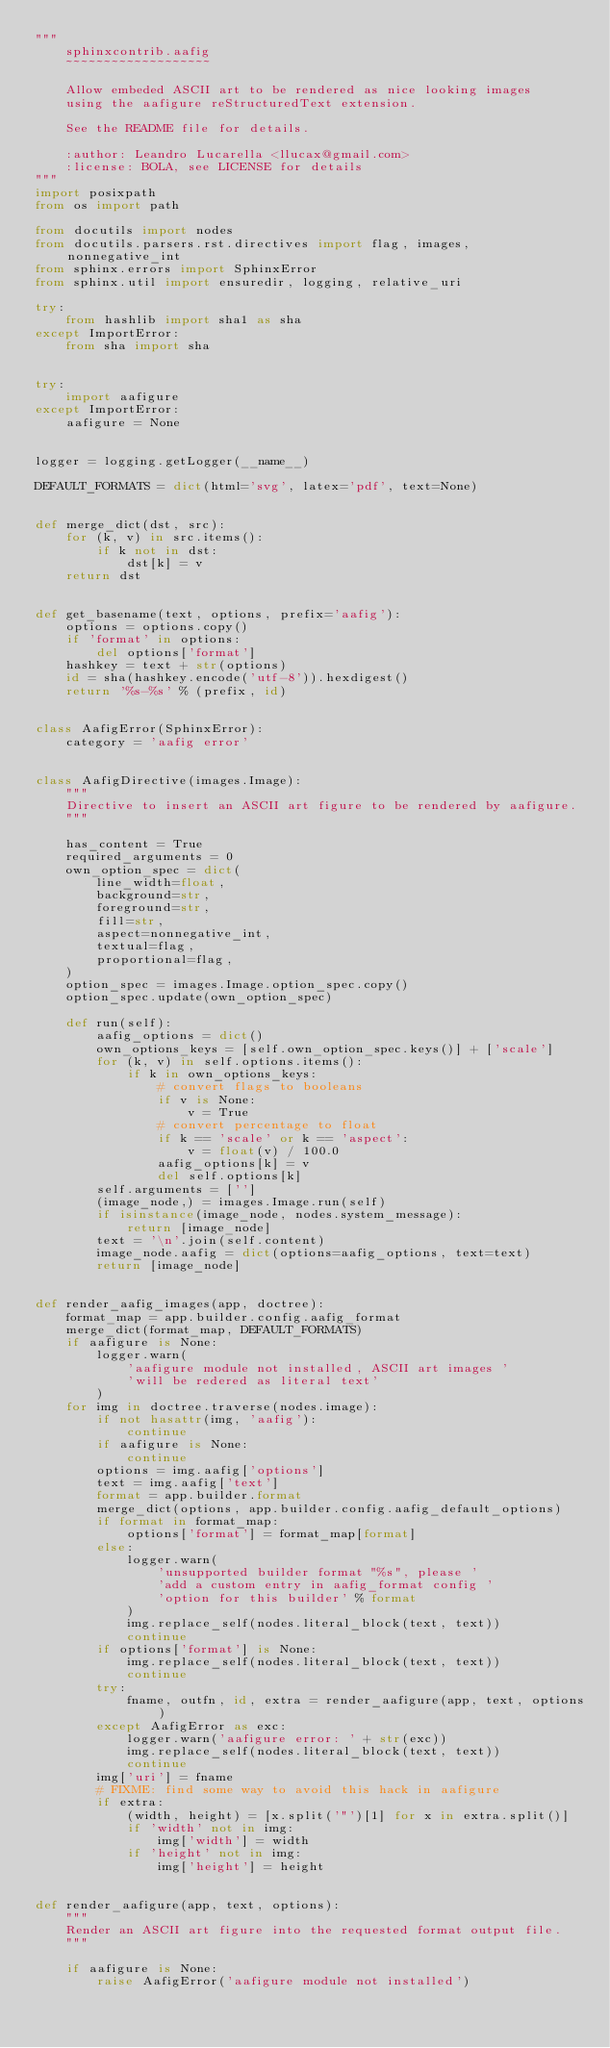<code> <loc_0><loc_0><loc_500><loc_500><_Python_>"""
    sphinxcontrib.aafig
    ~~~~~~~~~~~~~~~~~~~

    Allow embeded ASCII art to be rendered as nice looking images
    using the aafigure reStructuredText extension.

    See the README file for details.

    :author: Leandro Lucarella <llucax@gmail.com>
    :license: BOLA, see LICENSE for details
"""
import posixpath
from os import path

from docutils import nodes
from docutils.parsers.rst.directives import flag, images, nonnegative_int
from sphinx.errors import SphinxError
from sphinx.util import ensuredir, logging, relative_uri

try:
    from hashlib import sha1 as sha
except ImportError:
    from sha import sha


try:
    import aafigure
except ImportError:
    aafigure = None


logger = logging.getLogger(__name__)

DEFAULT_FORMATS = dict(html='svg', latex='pdf', text=None)


def merge_dict(dst, src):
    for (k, v) in src.items():
        if k not in dst:
            dst[k] = v
    return dst


def get_basename(text, options, prefix='aafig'):
    options = options.copy()
    if 'format' in options:
        del options['format']
    hashkey = text + str(options)
    id = sha(hashkey.encode('utf-8')).hexdigest()
    return '%s-%s' % (prefix, id)


class AafigError(SphinxError):
    category = 'aafig error'


class AafigDirective(images.Image):
    """
    Directive to insert an ASCII art figure to be rendered by aafigure.
    """

    has_content = True
    required_arguments = 0
    own_option_spec = dict(
        line_width=float,
        background=str,
        foreground=str,
        fill=str,
        aspect=nonnegative_int,
        textual=flag,
        proportional=flag,
    )
    option_spec = images.Image.option_spec.copy()
    option_spec.update(own_option_spec)

    def run(self):
        aafig_options = dict()
        own_options_keys = [self.own_option_spec.keys()] + ['scale']
        for (k, v) in self.options.items():
            if k in own_options_keys:
                # convert flags to booleans
                if v is None:
                    v = True
                # convert percentage to float
                if k == 'scale' or k == 'aspect':
                    v = float(v) / 100.0
                aafig_options[k] = v
                del self.options[k]
        self.arguments = ['']
        (image_node,) = images.Image.run(self)
        if isinstance(image_node, nodes.system_message):
            return [image_node]
        text = '\n'.join(self.content)
        image_node.aafig = dict(options=aafig_options, text=text)
        return [image_node]


def render_aafig_images(app, doctree):
    format_map = app.builder.config.aafig_format
    merge_dict(format_map, DEFAULT_FORMATS)
    if aafigure is None:
        logger.warn(
            'aafigure module not installed, ASCII art images '
            'will be redered as literal text'
        )
    for img in doctree.traverse(nodes.image):
        if not hasattr(img, 'aafig'):
            continue
        if aafigure is None:
            continue
        options = img.aafig['options']
        text = img.aafig['text']
        format = app.builder.format
        merge_dict(options, app.builder.config.aafig_default_options)
        if format in format_map:
            options['format'] = format_map[format]
        else:
            logger.warn(
                'unsupported builder format "%s", please '
                'add a custom entry in aafig_format config '
                'option for this builder' % format
            )
            img.replace_self(nodes.literal_block(text, text))
            continue
        if options['format'] is None:
            img.replace_self(nodes.literal_block(text, text))
            continue
        try:
            fname, outfn, id, extra = render_aafigure(app, text, options)
        except AafigError as exc:
            logger.warn('aafigure error: ' + str(exc))
            img.replace_self(nodes.literal_block(text, text))
            continue
        img['uri'] = fname
        # FIXME: find some way to avoid this hack in aafigure
        if extra:
            (width, height) = [x.split('"')[1] for x in extra.split()]
            if 'width' not in img:
                img['width'] = width
            if 'height' not in img:
                img['height'] = height


def render_aafigure(app, text, options):
    """
    Render an ASCII art figure into the requested format output file.
    """

    if aafigure is None:
        raise AafigError('aafigure module not installed')
</code> 